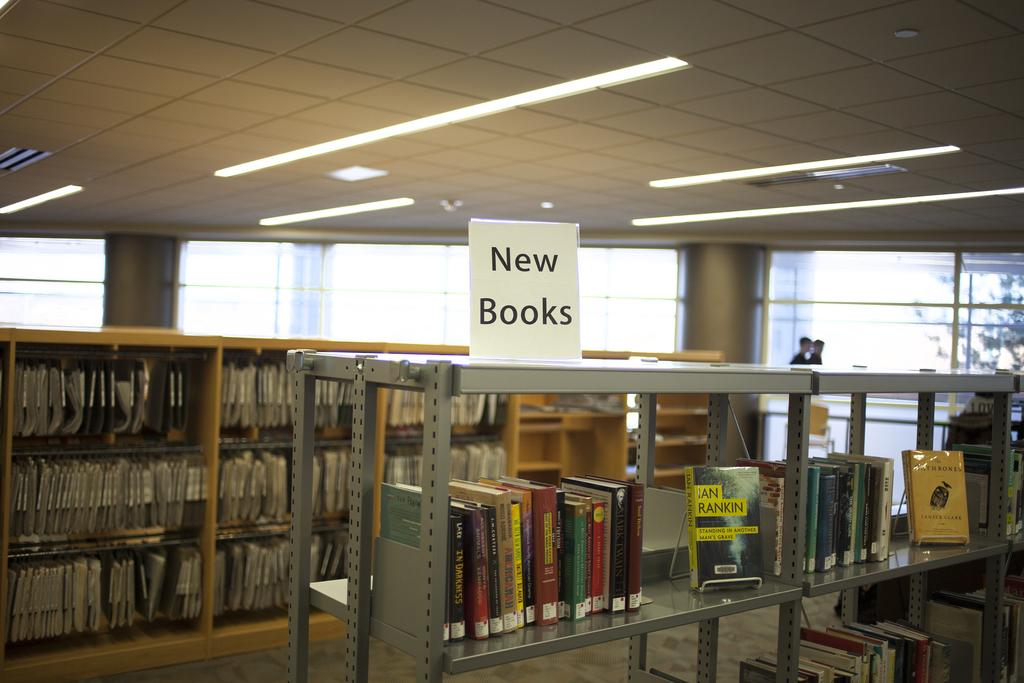Provide a one-sentence caption for the provided image. Book store with a sign that says New Books on top. 